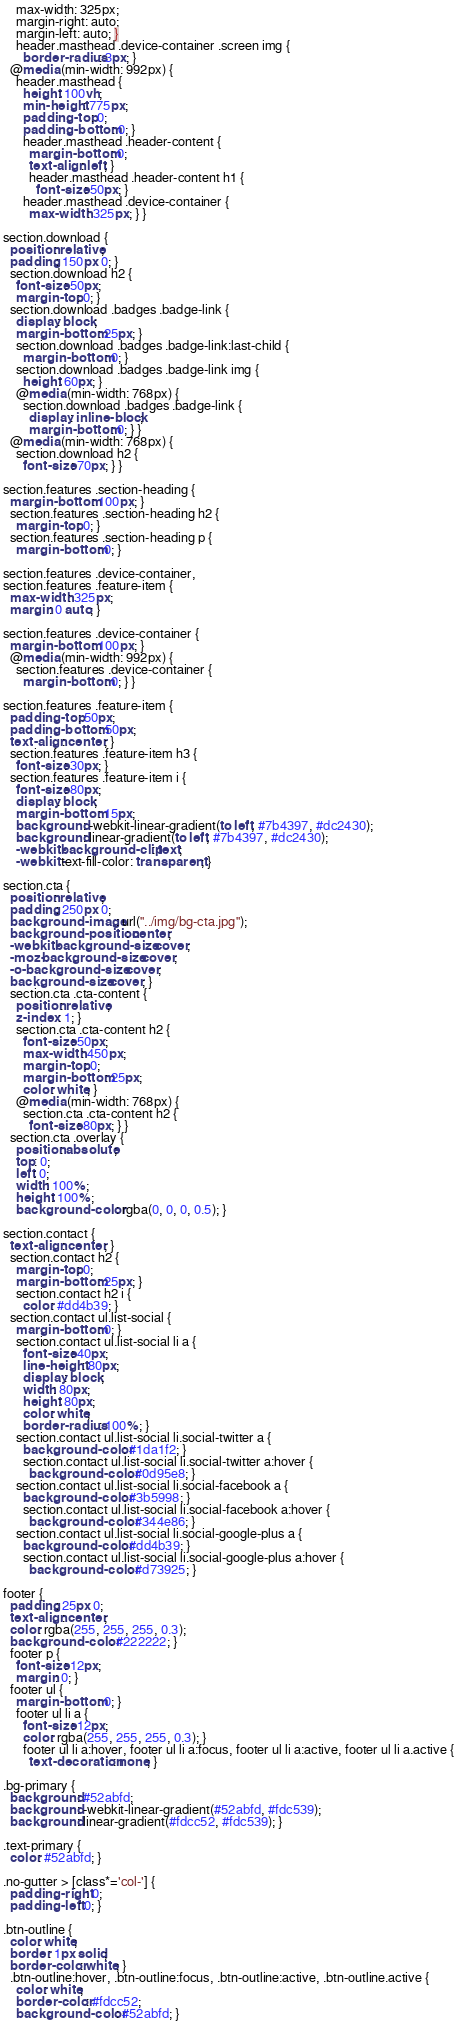<code> <loc_0><loc_0><loc_500><loc_500><_CSS_>    max-width: 325px;
    margin-right: auto;
    margin-left: auto; }
    header.masthead .device-container .screen img {
      border-radius: 3px; }
  @media (min-width: 992px) {
    header.masthead {
      height: 100vh;
      min-height: 775px;
      padding-top: 0;
      padding-bottom: 0; }
      header.masthead .header-content {
        margin-bottom: 0;
        text-align: left; }
        header.masthead .header-content h1 {
          font-size: 50px; }
      header.masthead .device-container {
        max-width: 325px; } }

section.download {
  position: relative;
  padding: 150px 0; }
  section.download h2 {
    font-size: 50px;
    margin-top: 0; }
  section.download .badges .badge-link {
    display: block;
    margin-bottom: 25px; }
    section.download .badges .badge-link:last-child {
      margin-bottom: 0; }
    section.download .badges .badge-link img {
      height: 60px; }
    @media (min-width: 768px) {
      section.download .badges .badge-link {
        display: inline-block;
        margin-bottom: 0; } }
  @media (min-width: 768px) {
    section.download h2 {
      font-size: 70px; } }

section.features .section-heading {
  margin-bottom: 100px; }
  section.features .section-heading h2 {
    margin-top: 0; }
  section.features .section-heading p {
    margin-bottom: 0; }

section.features .device-container,
section.features .feature-item {
  max-width: 325px;
  margin: 0 auto; }

section.features .device-container {
  margin-bottom: 100px; }
  @media (min-width: 992px) {
    section.features .device-container {
      margin-bottom: 0; } }

section.features .feature-item {
  padding-top: 50px;
  padding-bottom: 50px;
  text-align: center; }
  section.features .feature-item h3 {
    font-size: 30px; }
  section.features .feature-item i {
    font-size: 80px;
    display: block;
    margin-bottom: 15px;
    background: -webkit-linear-gradient(to left, #7b4397, #dc2430);
    background: linear-gradient(to left, #7b4397, #dc2430);
    -webkit-background-clip: text;
    -webkit-text-fill-color: transparent; }

section.cta {
  position: relative;
  padding: 250px 0;
  background-image: url("../img/bg-cta.jpg");
  background-position: center;
  -webkit-background-size: cover;
  -moz-background-size: cover;
  -o-background-size: cover;
  background-size: cover; }
  section.cta .cta-content {
    position: relative;
    z-index: 1; }
    section.cta .cta-content h2 {
      font-size: 50px;
      max-width: 450px;
      margin-top: 0;
      margin-bottom: 25px;
      color: white; }
    @media (min-width: 768px) {
      section.cta .cta-content h2 {
        font-size: 80px; } }
  section.cta .overlay {
    position: absolute;
    top: 0;
    left: 0;
    width: 100%;
    height: 100%;
    background-color: rgba(0, 0, 0, 0.5); }

section.contact {
  text-align: center; }
  section.contact h2 {
    margin-top: 0;
    margin-bottom: 25px; }
    section.contact h2 i {
      color: #dd4b39; }
  section.contact ul.list-social {
    margin-bottom: 0; }
    section.contact ul.list-social li a {
      font-size: 40px;
      line-height: 80px;
      display: block;
      width: 80px;
      height: 80px;
      color: white;
      border-radius: 100%; }
    section.contact ul.list-social li.social-twitter a {
      background-color: #1da1f2; }
      section.contact ul.list-social li.social-twitter a:hover {
        background-color: #0d95e8; }
    section.contact ul.list-social li.social-facebook a {
      background-color: #3b5998; }
      section.contact ul.list-social li.social-facebook a:hover {
        background-color: #344e86; }
    section.contact ul.list-social li.social-google-plus a {
      background-color: #dd4b39; }
      section.contact ul.list-social li.social-google-plus a:hover {
        background-color: #d73925; }

footer {
  padding: 25px 0;
  text-align: center;
  color: rgba(255, 255, 255, 0.3);
  background-color: #222222; }
  footer p {
    font-size: 12px;
    margin: 0; }
  footer ul {
    margin-bottom: 0; }
    footer ul li a {
      font-size: 12px;
      color: rgba(255, 255, 255, 0.3); }
      footer ul li a:hover, footer ul li a:focus, footer ul li a:active, footer ul li a.active {
        text-decoration: none; }

.bg-primary {
  background: #52abfd;
  background: -webkit-linear-gradient(#52abfd, #fdc539);
  background: linear-gradient(#fdcc52, #fdc539); }

.text-primary {
  color: #52abfd; }

.no-gutter > [class*='col-'] {
  padding-right: 0;
  padding-left: 0; }

.btn-outline {
  color: white;
  border: 1px solid;
  border-color: white; }
  .btn-outline:hover, .btn-outline:focus, .btn-outline:active, .btn-outline.active {
    color: white;
    border-color: #fdcc52;
    background-color: #52abfd; }
</code> 